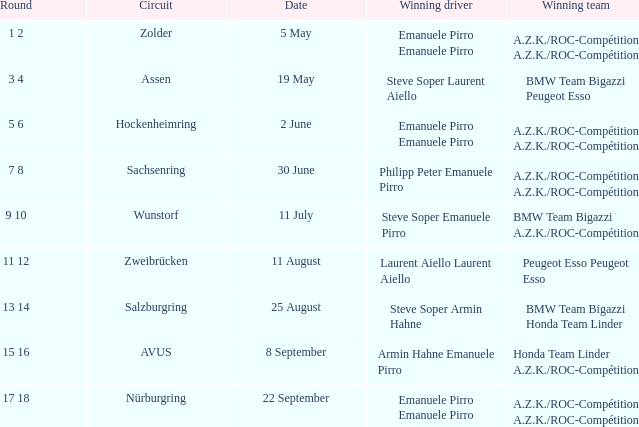On which date did the zolder circuit race take place, with a.z.k./roc-compétition as the victorious team? 5 May. 